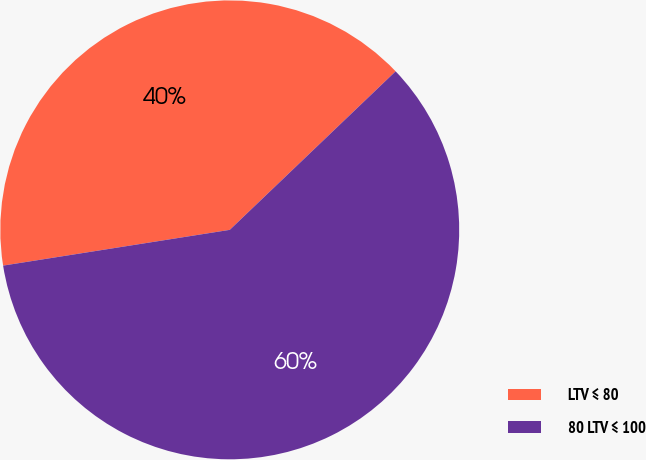<chart> <loc_0><loc_0><loc_500><loc_500><pie_chart><fcel>LTV ≤ 80<fcel>80 LTV ≤ 100<nl><fcel>40.35%<fcel>59.65%<nl></chart> 